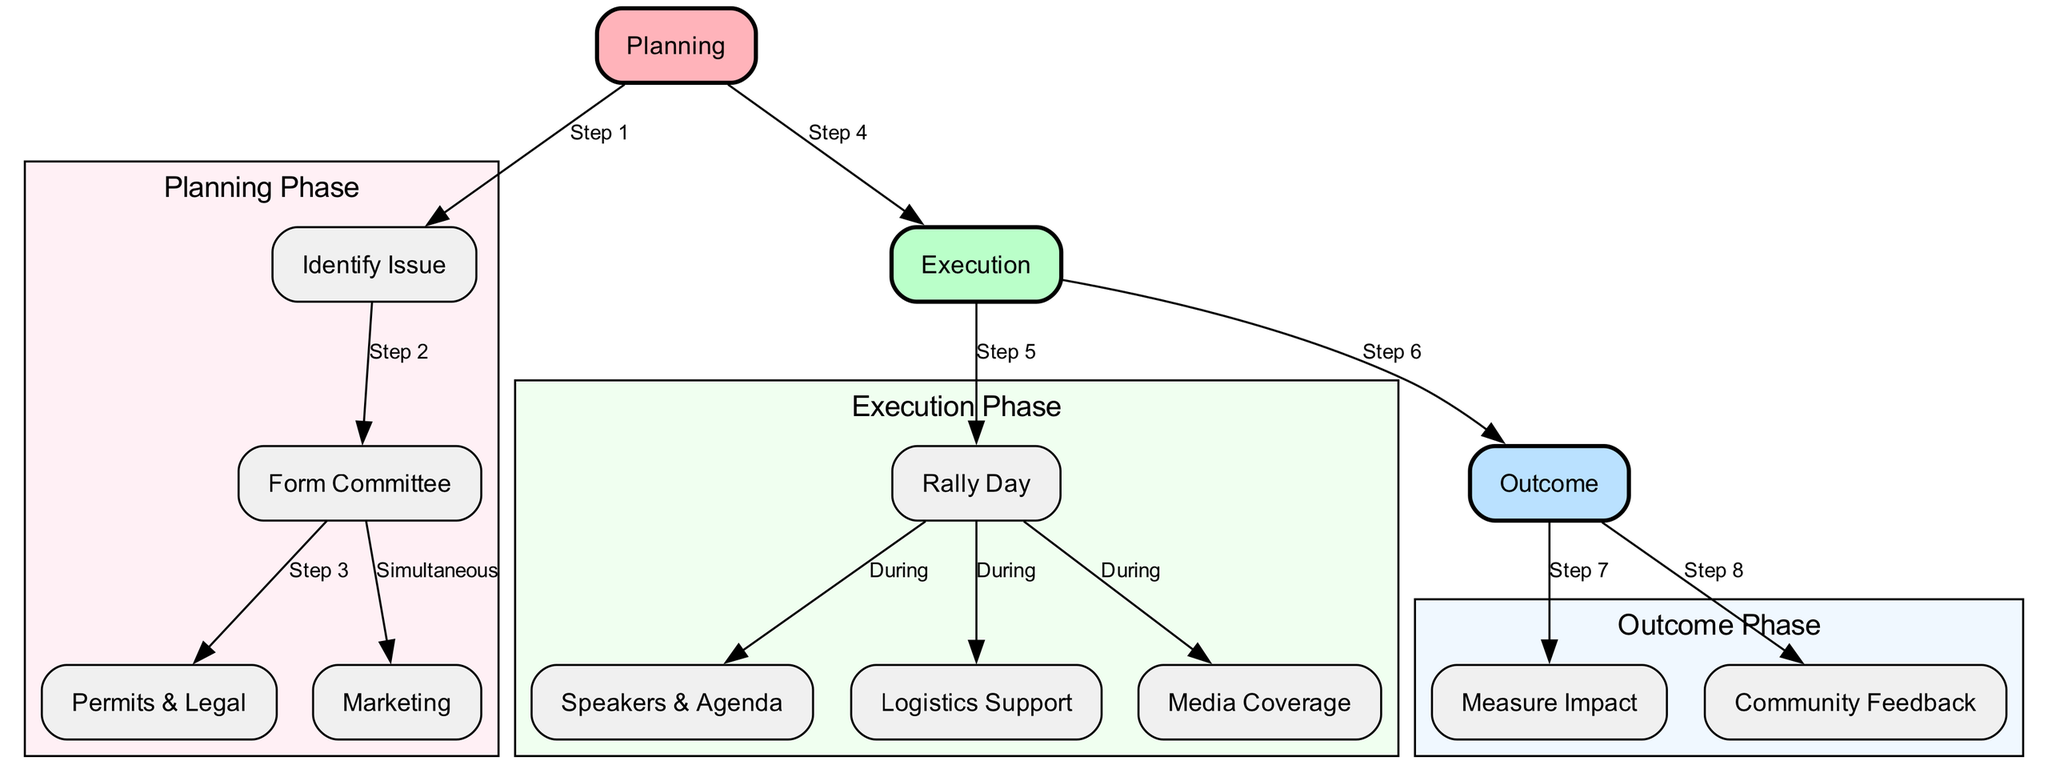What is the first step in the planning phase? The first step in the planning phase is represented by the node labeled "Identify Issue". This is indicated by the edge connecting "planning" to "identify_issue", which is marked as "Step 1".
Answer: Identify Issue How many nodes are there in the execution phase? The execution phase includes the nodes "Execution", "Rally Day", "Speakers & Agenda", "Logistics Support", and "Media Coverage". Counting these, there are five nodes in total in this phase.
Answer: 5 What follows "Form Committee" in the planning phase? After "Form Committee", the next steps indicated in the planning phase are "Permits & Legal" and "Marketing". They are connected by edges labeled "Step 3" and marked as "Simultaneous" respectively.
Answer: Permits & Legal, Marketing What is the outcome after the rally day? After "Rally Day", the diagram shows that the next step is "Outcome", which is connected by an edge labeled "Step 6". Thus, the outcome directly follows the rally day.
Answer: Outcome Which nodes are involved during the rally day? During the "Rally Day", the involved nodes include "Speakers & Agenda", "Logistics Support", and "Media Coverage". These nodes are connected with edges from "Rally Day" marked as "During".
Answer: Speakers & Agenda, Logistics Support, Media Coverage What is the last step of the protest workflow? The last step in the protest workflow is represented by the node labeled "Community Feedback". This connects to "Outcome", marked as "Step 8". Therefore, it is the final outcome in this workflow.
Answer: Community Feedback How many edges lead from the execution phase to the outcome phase? From the execution phase to the outcome phase, there are two edges leading out. One is to "Rally Day" marked as "Step 5" and the other is directly leading to the "Outcome" labeled as "Step 6". Therefore, there are two edges in total.
Answer: 2 Which phase contains the "Measure Impact" node? The "Measure Impact" node is contained within the outcome phase, which encapsulates all nodes involved after the protest has been executed. This is confirmed by its connection from "Outcome" marked as "Step 7".
Answer: Outcome 